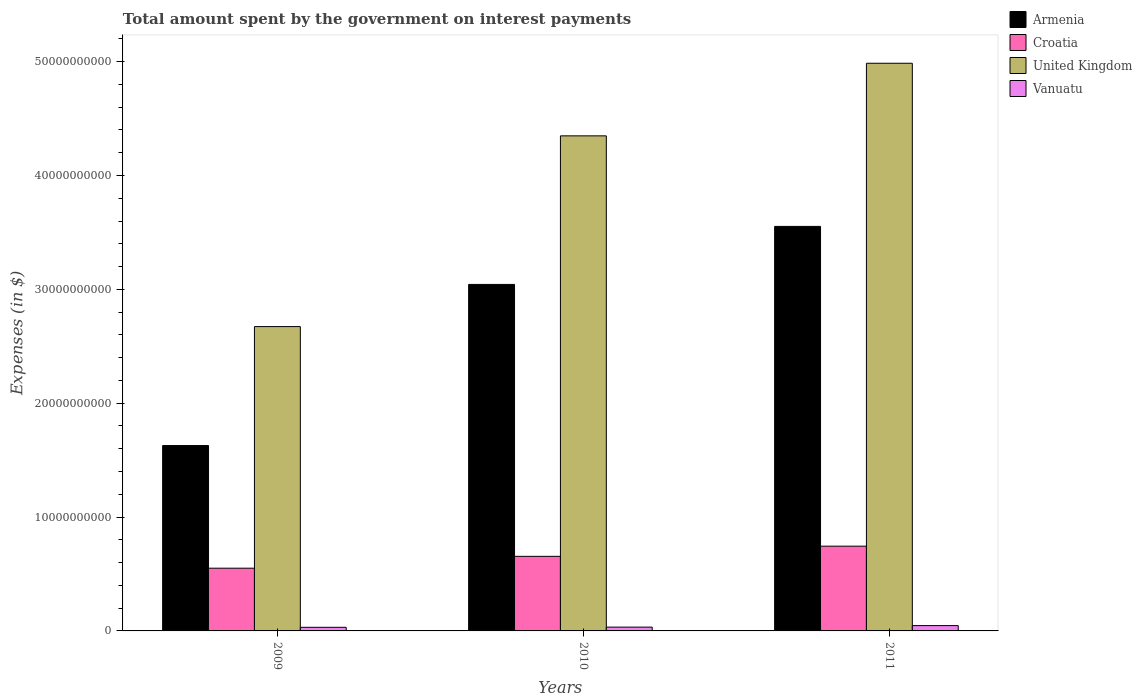Are the number of bars per tick equal to the number of legend labels?
Your answer should be compact. Yes. Are the number of bars on each tick of the X-axis equal?
Your response must be concise. Yes. How many bars are there on the 3rd tick from the right?
Give a very brief answer. 4. In how many cases, is the number of bars for a given year not equal to the number of legend labels?
Your answer should be very brief. 0. What is the amount spent on interest payments by the government in Armenia in 2011?
Offer a very short reply. 3.55e+1. Across all years, what is the maximum amount spent on interest payments by the government in Armenia?
Offer a terse response. 3.55e+1. Across all years, what is the minimum amount spent on interest payments by the government in Armenia?
Keep it short and to the point. 1.63e+1. What is the total amount spent on interest payments by the government in Armenia in the graph?
Provide a short and direct response. 8.22e+1. What is the difference between the amount spent on interest payments by the government in Vanuatu in 2009 and that in 2011?
Make the answer very short. -1.50e+08. What is the difference between the amount spent on interest payments by the government in Vanuatu in 2011 and the amount spent on interest payments by the government in Armenia in 2009?
Your answer should be very brief. -1.58e+1. What is the average amount spent on interest payments by the government in Vanuatu per year?
Offer a very short reply. 3.73e+08. In the year 2011, what is the difference between the amount spent on interest payments by the government in Vanuatu and amount spent on interest payments by the government in United Kingdom?
Ensure brevity in your answer.  -4.94e+1. In how many years, is the amount spent on interest payments by the government in Vanuatu greater than 14000000000 $?
Your answer should be very brief. 0. What is the ratio of the amount spent on interest payments by the government in Croatia in 2010 to that in 2011?
Your answer should be compact. 0.88. Is the difference between the amount spent on interest payments by the government in Vanuatu in 2009 and 2011 greater than the difference between the amount spent on interest payments by the government in United Kingdom in 2009 and 2011?
Make the answer very short. Yes. What is the difference between the highest and the second highest amount spent on interest payments by the government in Vanuatu?
Your response must be concise. 1.34e+08. What is the difference between the highest and the lowest amount spent on interest payments by the government in Croatia?
Your answer should be very brief. 1.93e+09. Is the sum of the amount spent on interest payments by the government in Croatia in 2009 and 2011 greater than the maximum amount spent on interest payments by the government in United Kingdom across all years?
Provide a short and direct response. No. Is it the case that in every year, the sum of the amount spent on interest payments by the government in Croatia and amount spent on interest payments by the government in Vanuatu is greater than the sum of amount spent on interest payments by the government in Armenia and amount spent on interest payments by the government in United Kingdom?
Keep it short and to the point. No. What does the 2nd bar from the left in 2009 represents?
Give a very brief answer. Croatia. What does the 3rd bar from the right in 2010 represents?
Offer a terse response. Croatia. Is it the case that in every year, the sum of the amount spent on interest payments by the government in United Kingdom and amount spent on interest payments by the government in Croatia is greater than the amount spent on interest payments by the government in Vanuatu?
Provide a succinct answer. Yes. How many bars are there?
Make the answer very short. 12. Are the values on the major ticks of Y-axis written in scientific E-notation?
Give a very brief answer. No. What is the title of the graph?
Give a very brief answer. Total amount spent by the government on interest payments. What is the label or title of the Y-axis?
Offer a terse response. Expenses (in $). What is the Expenses (in $) of Armenia in 2009?
Give a very brief answer. 1.63e+1. What is the Expenses (in $) of Croatia in 2009?
Your response must be concise. 5.51e+09. What is the Expenses (in $) in United Kingdom in 2009?
Make the answer very short. 2.67e+1. What is the Expenses (in $) of Vanuatu in 2009?
Your answer should be very brief. 3.18e+08. What is the Expenses (in $) of Armenia in 2010?
Offer a very short reply. 3.04e+1. What is the Expenses (in $) of Croatia in 2010?
Your answer should be very brief. 6.55e+09. What is the Expenses (in $) in United Kingdom in 2010?
Give a very brief answer. 4.35e+1. What is the Expenses (in $) in Vanuatu in 2010?
Make the answer very short. 3.34e+08. What is the Expenses (in $) of Armenia in 2011?
Your answer should be very brief. 3.55e+1. What is the Expenses (in $) in Croatia in 2011?
Your answer should be very brief. 7.44e+09. What is the Expenses (in $) of United Kingdom in 2011?
Offer a very short reply. 4.99e+1. What is the Expenses (in $) of Vanuatu in 2011?
Offer a terse response. 4.68e+08. Across all years, what is the maximum Expenses (in $) of Armenia?
Provide a short and direct response. 3.55e+1. Across all years, what is the maximum Expenses (in $) in Croatia?
Provide a short and direct response. 7.44e+09. Across all years, what is the maximum Expenses (in $) in United Kingdom?
Your response must be concise. 4.99e+1. Across all years, what is the maximum Expenses (in $) of Vanuatu?
Keep it short and to the point. 4.68e+08. Across all years, what is the minimum Expenses (in $) of Armenia?
Provide a short and direct response. 1.63e+1. Across all years, what is the minimum Expenses (in $) of Croatia?
Offer a very short reply. 5.51e+09. Across all years, what is the minimum Expenses (in $) in United Kingdom?
Your answer should be compact. 2.67e+1. Across all years, what is the minimum Expenses (in $) of Vanuatu?
Give a very brief answer. 3.18e+08. What is the total Expenses (in $) in Armenia in the graph?
Offer a very short reply. 8.22e+1. What is the total Expenses (in $) in Croatia in the graph?
Provide a short and direct response. 1.95e+1. What is the total Expenses (in $) of United Kingdom in the graph?
Provide a succinct answer. 1.20e+11. What is the total Expenses (in $) of Vanuatu in the graph?
Give a very brief answer. 1.12e+09. What is the difference between the Expenses (in $) in Armenia in 2009 and that in 2010?
Your answer should be compact. -1.42e+1. What is the difference between the Expenses (in $) of Croatia in 2009 and that in 2010?
Offer a terse response. -1.04e+09. What is the difference between the Expenses (in $) in United Kingdom in 2009 and that in 2010?
Keep it short and to the point. -1.68e+1. What is the difference between the Expenses (in $) of Vanuatu in 2009 and that in 2010?
Offer a very short reply. -1.57e+07. What is the difference between the Expenses (in $) of Armenia in 2009 and that in 2011?
Give a very brief answer. -1.93e+1. What is the difference between the Expenses (in $) of Croatia in 2009 and that in 2011?
Keep it short and to the point. -1.93e+09. What is the difference between the Expenses (in $) of United Kingdom in 2009 and that in 2011?
Offer a terse response. -2.31e+1. What is the difference between the Expenses (in $) in Vanuatu in 2009 and that in 2011?
Make the answer very short. -1.50e+08. What is the difference between the Expenses (in $) in Armenia in 2010 and that in 2011?
Your answer should be compact. -5.10e+09. What is the difference between the Expenses (in $) in Croatia in 2010 and that in 2011?
Offer a terse response. -8.93e+08. What is the difference between the Expenses (in $) in United Kingdom in 2010 and that in 2011?
Offer a very short reply. -6.38e+09. What is the difference between the Expenses (in $) in Vanuatu in 2010 and that in 2011?
Offer a terse response. -1.34e+08. What is the difference between the Expenses (in $) in Armenia in 2009 and the Expenses (in $) in Croatia in 2010?
Provide a succinct answer. 9.73e+09. What is the difference between the Expenses (in $) of Armenia in 2009 and the Expenses (in $) of United Kingdom in 2010?
Keep it short and to the point. -2.72e+1. What is the difference between the Expenses (in $) of Armenia in 2009 and the Expenses (in $) of Vanuatu in 2010?
Offer a very short reply. 1.59e+1. What is the difference between the Expenses (in $) in Croatia in 2009 and the Expenses (in $) in United Kingdom in 2010?
Keep it short and to the point. -3.80e+1. What is the difference between the Expenses (in $) in Croatia in 2009 and the Expenses (in $) in Vanuatu in 2010?
Your response must be concise. 5.18e+09. What is the difference between the Expenses (in $) in United Kingdom in 2009 and the Expenses (in $) in Vanuatu in 2010?
Your answer should be very brief. 2.64e+1. What is the difference between the Expenses (in $) in Armenia in 2009 and the Expenses (in $) in Croatia in 2011?
Give a very brief answer. 8.84e+09. What is the difference between the Expenses (in $) in Armenia in 2009 and the Expenses (in $) in United Kingdom in 2011?
Keep it short and to the point. -3.36e+1. What is the difference between the Expenses (in $) of Armenia in 2009 and the Expenses (in $) of Vanuatu in 2011?
Keep it short and to the point. 1.58e+1. What is the difference between the Expenses (in $) of Croatia in 2009 and the Expenses (in $) of United Kingdom in 2011?
Ensure brevity in your answer.  -4.44e+1. What is the difference between the Expenses (in $) of Croatia in 2009 and the Expenses (in $) of Vanuatu in 2011?
Ensure brevity in your answer.  5.04e+09. What is the difference between the Expenses (in $) of United Kingdom in 2009 and the Expenses (in $) of Vanuatu in 2011?
Keep it short and to the point. 2.63e+1. What is the difference between the Expenses (in $) in Armenia in 2010 and the Expenses (in $) in Croatia in 2011?
Offer a very short reply. 2.30e+1. What is the difference between the Expenses (in $) of Armenia in 2010 and the Expenses (in $) of United Kingdom in 2011?
Provide a succinct answer. -1.94e+1. What is the difference between the Expenses (in $) in Armenia in 2010 and the Expenses (in $) in Vanuatu in 2011?
Provide a short and direct response. 3.00e+1. What is the difference between the Expenses (in $) in Croatia in 2010 and the Expenses (in $) in United Kingdom in 2011?
Offer a terse response. -4.33e+1. What is the difference between the Expenses (in $) of Croatia in 2010 and the Expenses (in $) of Vanuatu in 2011?
Offer a terse response. 6.08e+09. What is the difference between the Expenses (in $) of United Kingdom in 2010 and the Expenses (in $) of Vanuatu in 2011?
Make the answer very short. 4.30e+1. What is the average Expenses (in $) in Armenia per year?
Provide a short and direct response. 2.74e+1. What is the average Expenses (in $) of Croatia per year?
Offer a very short reply. 6.50e+09. What is the average Expenses (in $) of United Kingdom per year?
Offer a very short reply. 4.00e+1. What is the average Expenses (in $) in Vanuatu per year?
Offer a terse response. 3.73e+08. In the year 2009, what is the difference between the Expenses (in $) in Armenia and Expenses (in $) in Croatia?
Your response must be concise. 1.08e+1. In the year 2009, what is the difference between the Expenses (in $) of Armenia and Expenses (in $) of United Kingdom?
Offer a terse response. -1.05e+1. In the year 2009, what is the difference between the Expenses (in $) of Armenia and Expenses (in $) of Vanuatu?
Keep it short and to the point. 1.60e+1. In the year 2009, what is the difference between the Expenses (in $) in Croatia and Expenses (in $) in United Kingdom?
Provide a succinct answer. -2.12e+1. In the year 2009, what is the difference between the Expenses (in $) in Croatia and Expenses (in $) in Vanuatu?
Provide a succinct answer. 5.19e+09. In the year 2009, what is the difference between the Expenses (in $) of United Kingdom and Expenses (in $) of Vanuatu?
Provide a succinct answer. 2.64e+1. In the year 2010, what is the difference between the Expenses (in $) in Armenia and Expenses (in $) in Croatia?
Your response must be concise. 2.39e+1. In the year 2010, what is the difference between the Expenses (in $) in Armenia and Expenses (in $) in United Kingdom?
Your response must be concise. -1.30e+1. In the year 2010, what is the difference between the Expenses (in $) of Armenia and Expenses (in $) of Vanuatu?
Your response must be concise. 3.01e+1. In the year 2010, what is the difference between the Expenses (in $) of Croatia and Expenses (in $) of United Kingdom?
Offer a terse response. -3.69e+1. In the year 2010, what is the difference between the Expenses (in $) in Croatia and Expenses (in $) in Vanuatu?
Provide a succinct answer. 6.22e+09. In the year 2010, what is the difference between the Expenses (in $) of United Kingdom and Expenses (in $) of Vanuatu?
Provide a succinct answer. 4.32e+1. In the year 2011, what is the difference between the Expenses (in $) of Armenia and Expenses (in $) of Croatia?
Give a very brief answer. 2.81e+1. In the year 2011, what is the difference between the Expenses (in $) of Armenia and Expenses (in $) of United Kingdom?
Offer a very short reply. -1.43e+1. In the year 2011, what is the difference between the Expenses (in $) in Armenia and Expenses (in $) in Vanuatu?
Offer a very short reply. 3.51e+1. In the year 2011, what is the difference between the Expenses (in $) of Croatia and Expenses (in $) of United Kingdom?
Your answer should be very brief. -4.24e+1. In the year 2011, what is the difference between the Expenses (in $) in Croatia and Expenses (in $) in Vanuatu?
Make the answer very short. 6.98e+09. In the year 2011, what is the difference between the Expenses (in $) of United Kingdom and Expenses (in $) of Vanuatu?
Your response must be concise. 4.94e+1. What is the ratio of the Expenses (in $) of Armenia in 2009 to that in 2010?
Your response must be concise. 0.53. What is the ratio of the Expenses (in $) in Croatia in 2009 to that in 2010?
Make the answer very short. 0.84. What is the ratio of the Expenses (in $) of United Kingdom in 2009 to that in 2010?
Your response must be concise. 0.61. What is the ratio of the Expenses (in $) in Vanuatu in 2009 to that in 2010?
Your answer should be compact. 0.95. What is the ratio of the Expenses (in $) in Armenia in 2009 to that in 2011?
Your answer should be compact. 0.46. What is the ratio of the Expenses (in $) of Croatia in 2009 to that in 2011?
Ensure brevity in your answer.  0.74. What is the ratio of the Expenses (in $) in United Kingdom in 2009 to that in 2011?
Provide a succinct answer. 0.54. What is the ratio of the Expenses (in $) in Vanuatu in 2009 to that in 2011?
Your answer should be compact. 0.68. What is the ratio of the Expenses (in $) of Armenia in 2010 to that in 2011?
Offer a terse response. 0.86. What is the ratio of the Expenses (in $) in Croatia in 2010 to that in 2011?
Provide a short and direct response. 0.88. What is the ratio of the Expenses (in $) in United Kingdom in 2010 to that in 2011?
Ensure brevity in your answer.  0.87. What is the ratio of the Expenses (in $) in Vanuatu in 2010 to that in 2011?
Provide a short and direct response. 0.71. What is the difference between the highest and the second highest Expenses (in $) in Armenia?
Your response must be concise. 5.10e+09. What is the difference between the highest and the second highest Expenses (in $) of Croatia?
Give a very brief answer. 8.93e+08. What is the difference between the highest and the second highest Expenses (in $) in United Kingdom?
Make the answer very short. 6.38e+09. What is the difference between the highest and the second highest Expenses (in $) of Vanuatu?
Provide a succinct answer. 1.34e+08. What is the difference between the highest and the lowest Expenses (in $) of Armenia?
Give a very brief answer. 1.93e+1. What is the difference between the highest and the lowest Expenses (in $) of Croatia?
Provide a succinct answer. 1.93e+09. What is the difference between the highest and the lowest Expenses (in $) in United Kingdom?
Provide a succinct answer. 2.31e+1. What is the difference between the highest and the lowest Expenses (in $) of Vanuatu?
Provide a short and direct response. 1.50e+08. 